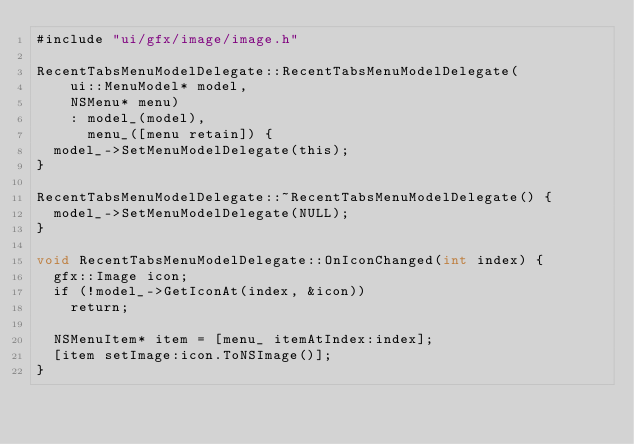<code> <loc_0><loc_0><loc_500><loc_500><_ObjectiveC_>#include "ui/gfx/image/image.h"

RecentTabsMenuModelDelegate::RecentTabsMenuModelDelegate(
    ui::MenuModel* model,
    NSMenu* menu)
    : model_(model),
      menu_([menu retain]) {
  model_->SetMenuModelDelegate(this);
}

RecentTabsMenuModelDelegate::~RecentTabsMenuModelDelegate() {
  model_->SetMenuModelDelegate(NULL);
}

void RecentTabsMenuModelDelegate::OnIconChanged(int index) {
  gfx::Image icon;
  if (!model_->GetIconAt(index, &icon))
    return;

  NSMenuItem* item = [menu_ itemAtIndex:index];
  [item setImage:icon.ToNSImage()];
}
</code> 